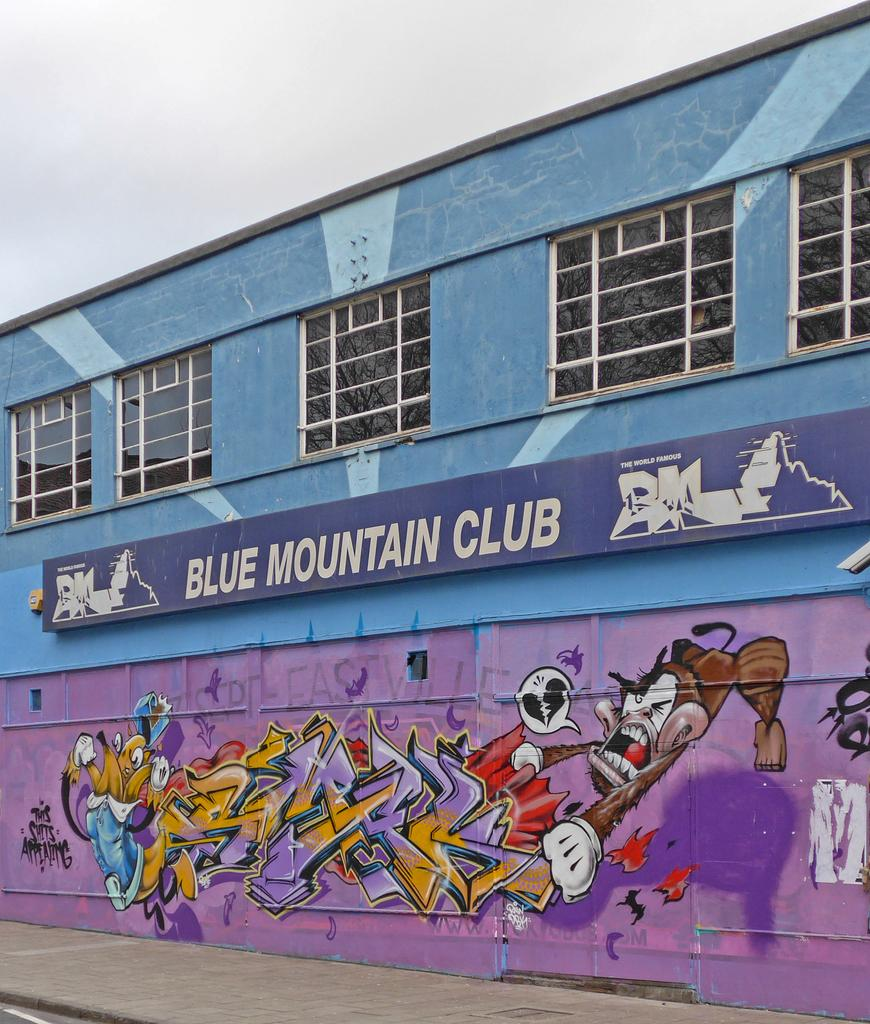<image>
Share a concise interpretation of the image provided. Blue Mountain Club reads the banner across this building. 